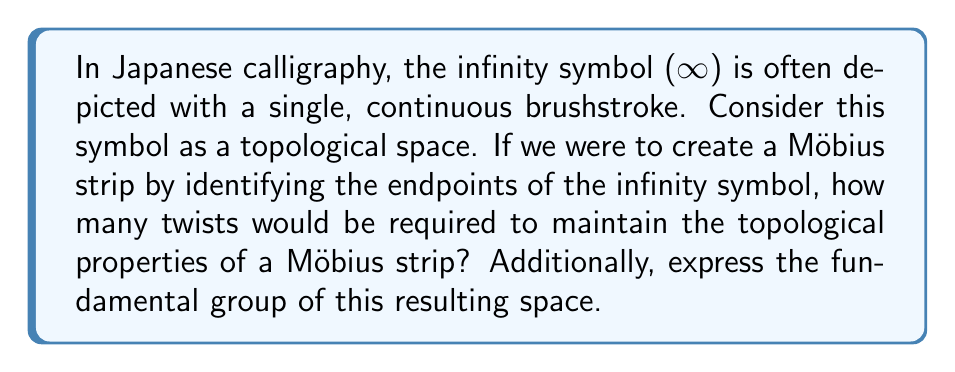What is the answer to this math problem? To approach this problem, let's consider the steps:

1. Visualize the infinity symbol (∞) as a topological space:
   The infinity symbol can be thought of as two circles touching at a single point.

2. Identify the endpoints:
   In this case, we don't have distinct endpoints as the symbol is already closed.

3. Creating a Möbius strip:
   To create a Möbius strip from this shape, we need to introduce a twist. The number of twists is crucial:
   - An even number of half-twists would result in a cylindrical band (orientable surface).
   - An odd number of half-twists would result in a Möbius strip (non-orientable surface).

4. Minimum twists required:
   The minimum number of half-twists needed to create a Möbius strip is one.

5. Fundamental group:
   To determine the fundamental group, we need to consider the resulting topological space:
   - A Möbius strip is homotopy equivalent to a circle.
   - The fundamental group of a circle is isomorphic to the integers under addition, denoted as ℤ.

Therefore, the fundamental group of the resulting space can be expressed as:

$$ \pi_1(M) \cong \mathbb{Z} $$

Where $M$ represents the Möbius strip formed from the infinity symbol, and $\pi_1$ denotes the fundamental group.
Answer: One half-twist is required to maintain the topological properties of a Möbius strip when identifying the endpoints of the infinity symbol. The fundamental group of the resulting space is isomorphic to ℤ, expressed as $\pi_1(M) \cong \mathbb{Z}$. 